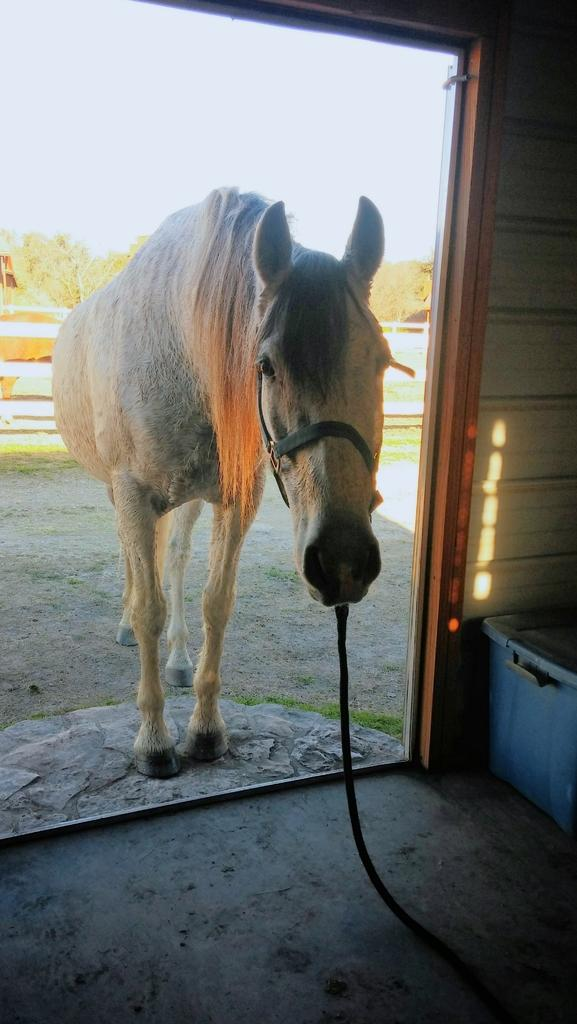What animal is present in the image? There is a horse in the image. How is the horse secured in the image? The horse is tied to a rope. Where is the horse located in relation to an entrance? The horse is standing outside an entrance. What can be seen in the background of the image? There are trees in the background of the image. What part of the natural environment is visible above the horse? The sky is visible above the horse. Is there a cave visible in the image? There is no cave present in the image. Does the horse's existence in the image prove the existence of unicorns? The horse's existence in the image does not prove the existence of unicorns, as the horse is a real-world animal and not a mythical creature. 